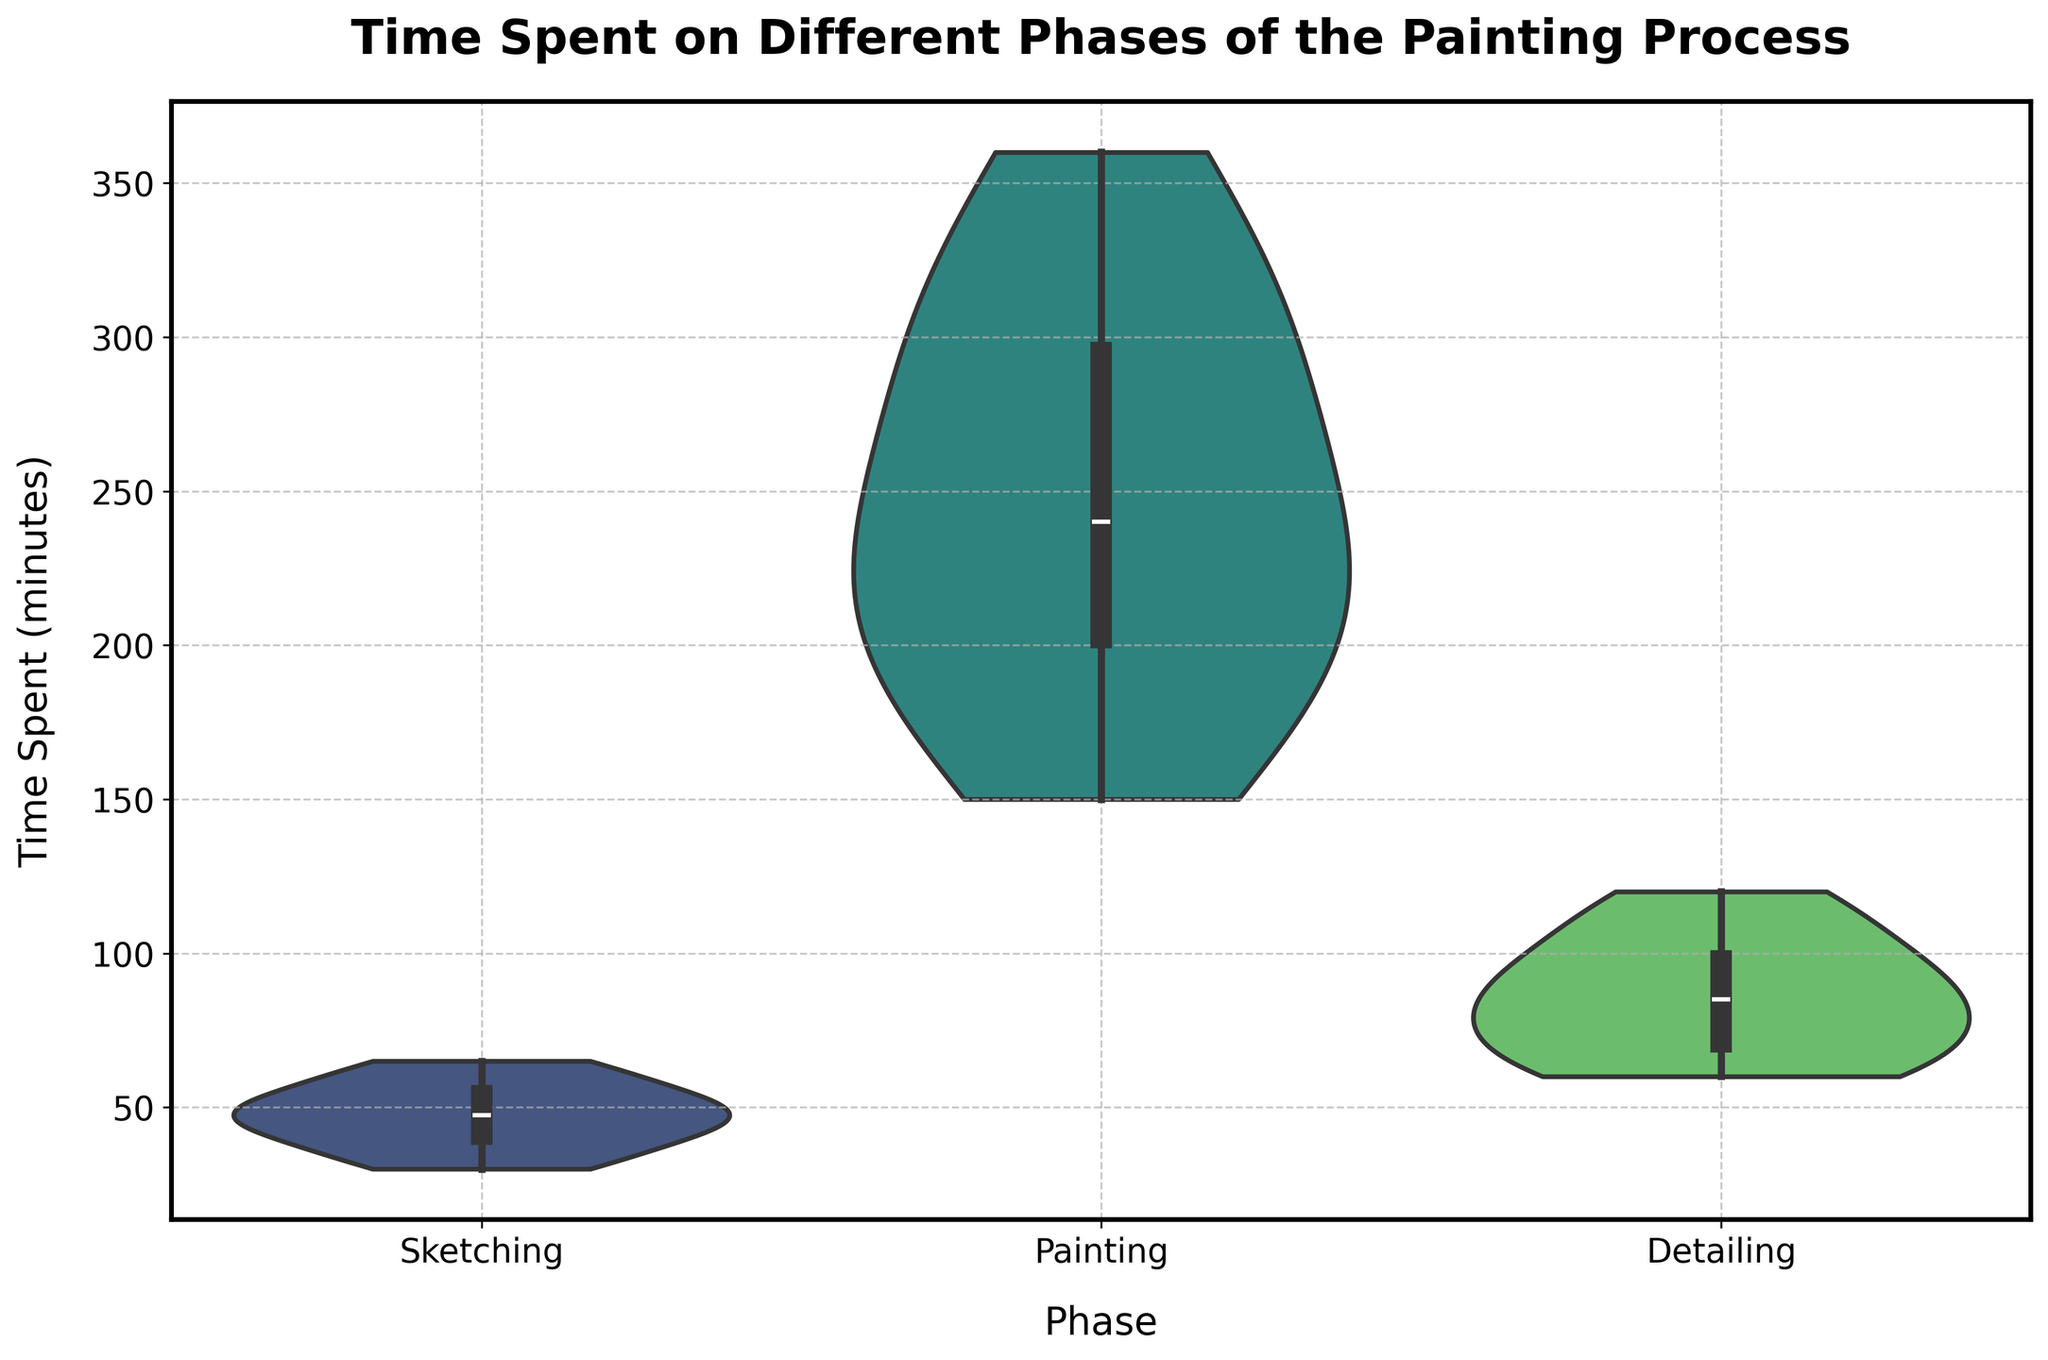What are the three phases shown in the chart? The x-axis of the violin chart lists the three phases evaluated in the study. These are labeled explicitly above the individual violin plots.
Answer: Sketching, Painting, Detailing What is the title of the chart? The title of the chart is usually found at the top of the figure in a larger, bold font to make it easily noticeable.
Answer: Time Spent on Different Phases of the Painting Process Which phase on average takes the longest time? By observing the distribution and concentration of values in the violin plots, Painting has the highest range and concentration towards the higher time spent.
Answer: Painting How does the time spent on sketching compare with painting? The violin plot for painting shows a much higher range and boxplot median than sketching, indicating that painting generally takes more time than sketching.
Answer: Painting takes more time than sketching What phase exhibits the greatest variability in time spent? Variability in a violin plot can be observed by the width and spread of the distribution. The painting phase has the widest range, indicating the greatest variability.
Answer: Painting What is the median time spent on detailing? The median can be identified by the line within the boxplot inside the violin plot for detailing. It's consistently around the middle mark of the wider section.
Answer: Approximately 90 minutes How does the median time spent on sketching compare to detailing? By examining the boxplot line for Sketching and Detailing, the median for sketching is lower compared to the median for detailing.
Answer: Sketching has a lower median than detailing Which phase has the least variability in time spent? The violin plot for sketching is less spread out and narrower compared to painting and detailing, indicating lower variability.
Answer: Sketching What can you infer about the peak density of time spent on painting? The peak density, or the area where most instances fall, appears towards the higher range in the violin plot for painting, indicating that a majority of time spent falls towards the higher end.
Answer: Higher range Looking at the distribution, which phase shows a bimodal distribution, if any? A bimodal distribution appears as two separate peaks within the violin plot. This is most pronounced in the detailing phase, as indicated by two wider sections in the plot.
Answer: Detailing 